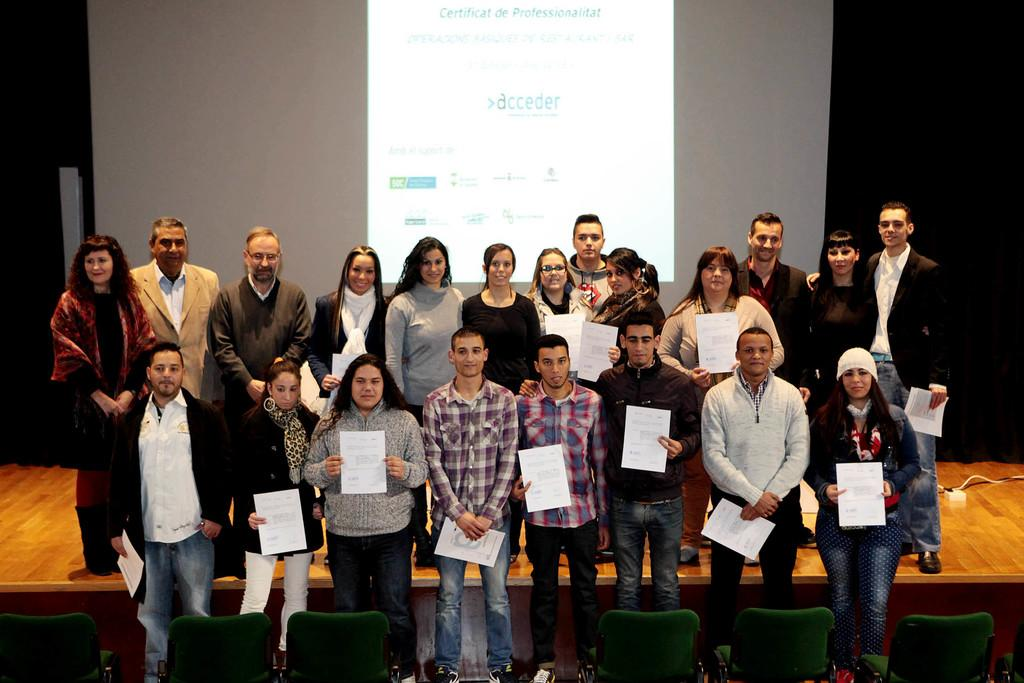What are the people in the image doing? The people in the center of the image are standing and holding papers in their hands. What objects are present at the bottom of the image? There are chairs at the bottom of the image. What can be seen in the background of the image? There is a screen and curtains in the background of the image. Can you tell me how many owls are sitting on the chairs in the image? There are no owls present in the image; it features people standing with papers and chairs in the background. What type of sugar is being used by the people in the image? There is no sugar visible in the image, as it only shows people holding papers and chairs in the background. 